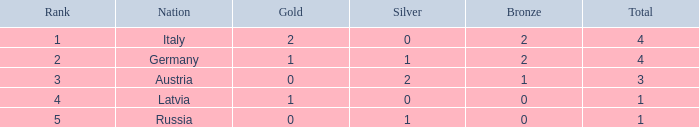What is the average gold medals for countries with more than 0 bronze, more than 0 silver, rank over 2 and total over 3? None. 